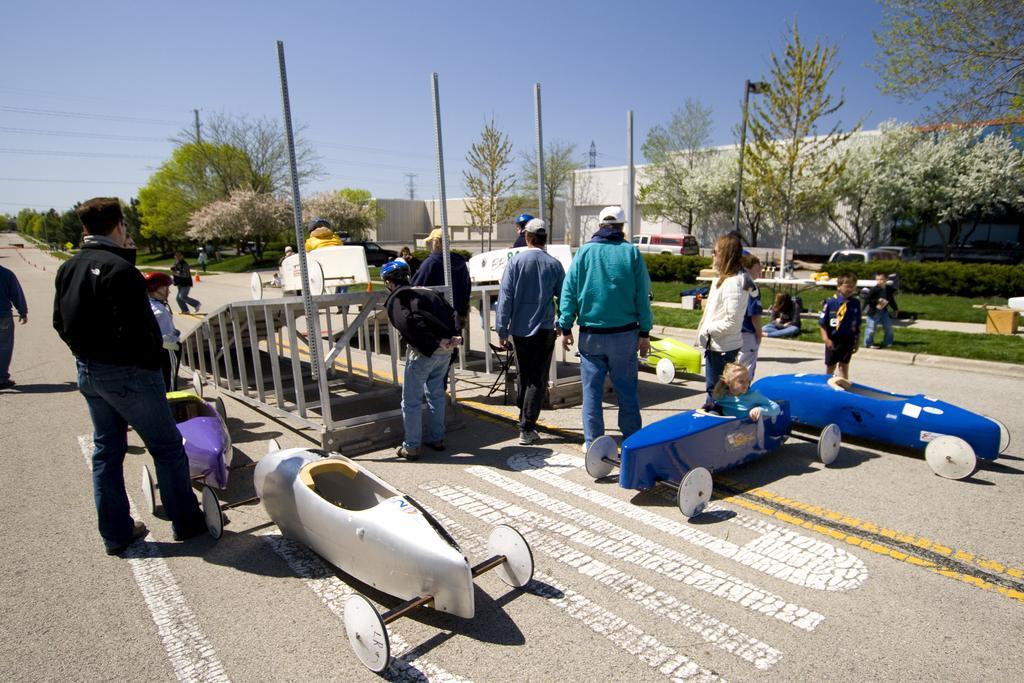In one or two sentences, can you explain what this image depicts? In this picture we can see some people are standing on the road and playing with kids, beside we can see some trees and buildings. 